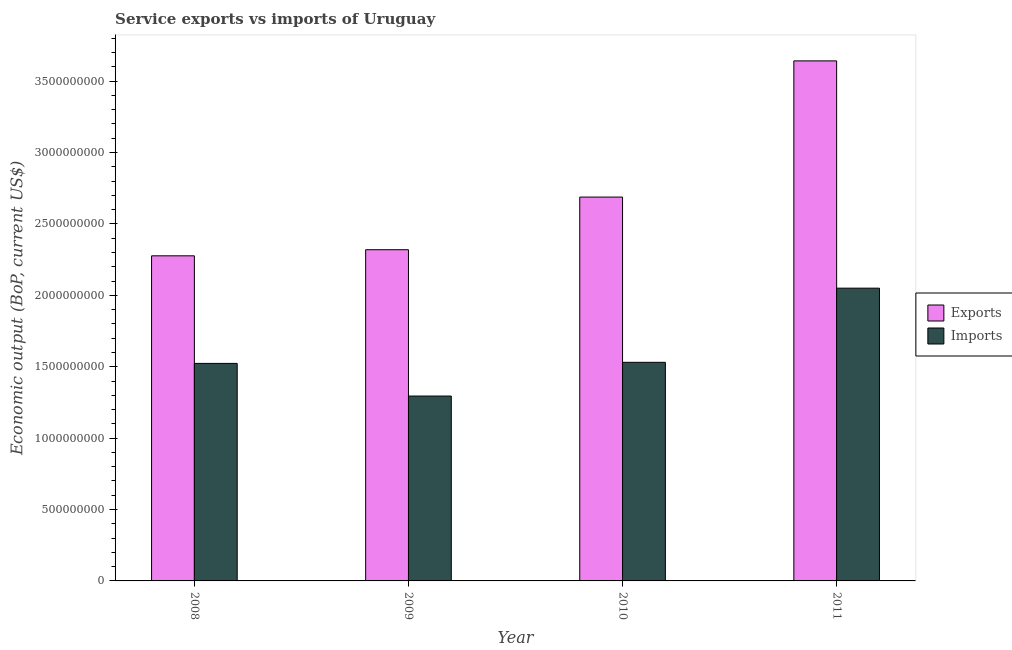How many different coloured bars are there?
Keep it short and to the point. 2. How many groups of bars are there?
Your answer should be compact. 4. Are the number of bars per tick equal to the number of legend labels?
Offer a terse response. Yes. Are the number of bars on each tick of the X-axis equal?
Provide a short and direct response. Yes. What is the label of the 1st group of bars from the left?
Your answer should be compact. 2008. What is the amount of service imports in 2010?
Your answer should be compact. 1.53e+09. Across all years, what is the maximum amount of service imports?
Your response must be concise. 2.05e+09. Across all years, what is the minimum amount of service imports?
Make the answer very short. 1.29e+09. In which year was the amount of service exports maximum?
Offer a very short reply. 2011. What is the total amount of service imports in the graph?
Offer a very short reply. 6.40e+09. What is the difference between the amount of service imports in 2008 and that in 2010?
Ensure brevity in your answer.  -7.59e+06. What is the difference between the amount of service imports in 2008 and the amount of service exports in 2010?
Make the answer very short. -7.59e+06. What is the average amount of service imports per year?
Make the answer very short. 1.60e+09. In the year 2011, what is the difference between the amount of service exports and amount of service imports?
Ensure brevity in your answer.  0. In how many years, is the amount of service exports greater than 2200000000 US$?
Offer a very short reply. 4. What is the ratio of the amount of service exports in 2010 to that in 2011?
Offer a terse response. 0.74. Is the amount of service imports in 2009 less than that in 2010?
Ensure brevity in your answer.  Yes. Is the difference between the amount of service exports in 2009 and 2011 greater than the difference between the amount of service imports in 2009 and 2011?
Your response must be concise. No. What is the difference between the highest and the second highest amount of service exports?
Keep it short and to the point. 9.54e+08. What is the difference between the highest and the lowest amount of service exports?
Offer a very short reply. 1.37e+09. What does the 2nd bar from the left in 2011 represents?
Your answer should be very brief. Imports. What does the 1st bar from the right in 2010 represents?
Provide a short and direct response. Imports. How many bars are there?
Keep it short and to the point. 8. How many years are there in the graph?
Keep it short and to the point. 4. Does the graph contain any zero values?
Make the answer very short. No. Does the graph contain grids?
Your answer should be very brief. No. Where does the legend appear in the graph?
Your answer should be very brief. Center right. What is the title of the graph?
Keep it short and to the point. Service exports vs imports of Uruguay. What is the label or title of the Y-axis?
Your response must be concise. Economic output (BoP, current US$). What is the Economic output (BoP, current US$) of Exports in 2008?
Your answer should be very brief. 2.28e+09. What is the Economic output (BoP, current US$) in Imports in 2008?
Offer a very short reply. 1.52e+09. What is the Economic output (BoP, current US$) in Exports in 2009?
Keep it short and to the point. 2.32e+09. What is the Economic output (BoP, current US$) of Imports in 2009?
Provide a succinct answer. 1.29e+09. What is the Economic output (BoP, current US$) in Exports in 2010?
Give a very brief answer. 2.69e+09. What is the Economic output (BoP, current US$) of Imports in 2010?
Your response must be concise. 1.53e+09. What is the Economic output (BoP, current US$) in Exports in 2011?
Your answer should be compact. 3.64e+09. What is the Economic output (BoP, current US$) of Imports in 2011?
Provide a short and direct response. 2.05e+09. Across all years, what is the maximum Economic output (BoP, current US$) in Exports?
Make the answer very short. 3.64e+09. Across all years, what is the maximum Economic output (BoP, current US$) in Imports?
Your answer should be compact. 2.05e+09. Across all years, what is the minimum Economic output (BoP, current US$) in Exports?
Your answer should be very brief. 2.28e+09. Across all years, what is the minimum Economic output (BoP, current US$) in Imports?
Offer a very short reply. 1.29e+09. What is the total Economic output (BoP, current US$) in Exports in the graph?
Ensure brevity in your answer.  1.09e+1. What is the total Economic output (BoP, current US$) in Imports in the graph?
Make the answer very short. 6.40e+09. What is the difference between the Economic output (BoP, current US$) of Exports in 2008 and that in 2009?
Ensure brevity in your answer.  -4.27e+07. What is the difference between the Economic output (BoP, current US$) in Imports in 2008 and that in 2009?
Make the answer very short. 2.29e+08. What is the difference between the Economic output (BoP, current US$) of Exports in 2008 and that in 2010?
Your response must be concise. -4.11e+08. What is the difference between the Economic output (BoP, current US$) in Imports in 2008 and that in 2010?
Your answer should be compact. -7.59e+06. What is the difference between the Economic output (BoP, current US$) of Exports in 2008 and that in 2011?
Offer a very short reply. -1.37e+09. What is the difference between the Economic output (BoP, current US$) in Imports in 2008 and that in 2011?
Keep it short and to the point. -5.27e+08. What is the difference between the Economic output (BoP, current US$) in Exports in 2009 and that in 2010?
Ensure brevity in your answer.  -3.69e+08. What is the difference between the Economic output (BoP, current US$) in Imports in 2009 and that in 2010?
Make the answer very short. -2.36e+08. What is the difference between the Economic output (BoP, current US$) in Exports in 2009 and that in 2011?
Keep it short and to the point. -1.32e+09. What is the difference between the Economic output (BoP, current US$) in Imports in 2009 and that in 2011?
Keep it short and to the point. -7.56e+08. What is the difference between the Economic output (BoP, current US$) of Exports in 2010 and that in 2011?
Your answer should be compact. -9.54e+08. What is the difference between the Economic output (BoP, current US$) of Imports in 2010 and that in 2011?
Keep it short and to the point. -5.19e+08. What is the difference between the Economic output (BoP, current US$) of Exports in 2008 and the Economic output (BoP, current US$) of Imports in 2009?
Your response must be concise. 9.82e+08. What is the difference between the Economic output (BoP, current US$) in Exports in 2008 and the Economic output (BoP, current US$) in Imports in 2010?
Your answer should be compact. 7.46e+08. What is the difference between the Economic output (BoP, current US$) in Exports in 2008 and the Economic output (BoP, current US$) in Imports in 2011?
Offer a very short reply. 2.26e+08. What is the difference between the Economic output (BoP, current US$) of Exports in 2009 and the Economic output (BoP, current US$) of Imports in 2010?
Provide a succinct answer. 7.89e+08. What is the difference between the Economic output (BoP, current US$) in Exports in 2009 and the Economic output (BoP, current US$) in Imports in 2011?
Offer a terse response. 2.69e+08. What is the difference between the Economic output (BoP, current US$) of Exports in 2010 and the Economic output (BoP, current US$) of Imports in 2011?
Provide a short and direct response. 6.38e+08. What is the average Economic output (BoP, current US$) of Exports per year?
Ensure brevity in your answer.  2.73e+09. What is the average Economic output (BoP, current US$) of Imports per year?
Ensure brevity in your answer.  1.60e+09. In the year 2008, what is the difference between the Economic output (BoP, current US$) of Exports and Economic output (BoP, current US$) of Imports?
Your answer should be compact. 7.53e+08. In the year 2009, what is the difference between the Economic output (BoP, current US$) of Exports and Economic output (BoP, current US$) of Imports?
Give a very brief answer. 1.02e+09. In the year 2010, what is the difference between the Economic output (BoP, current US$) of Exports and Economic output (BoP, current US$) of Imports?
Your answer should be compact. 1.16e+09. In the year 2011, what is the difference between the Economic output (BoP, current US$) in Exports and Economic output (BoP, current US$) in Imports?
Your response must be concise. 1.59e+09. What is the ratio of the Economic output (BoP, current US$) in Exports in 2008 to that in 2009?
Your response must be concise. 0.98. What is the ratio of the Economic output (BoP, current US$) in Imports in 2008 to that in 2009?
Provide a succinct answer. 1.18. What is the ratio of the Economic output (BoP, current US$) of Exports in 2008 to that in 2010?
Ensure brevity in your answer.  0.85. What is the ratio of the Economic output (BoP, current US$) in Exports in 2008 to that in 2011?
Ensure brevity in your answer.  0.63. What is the ratio of the Economic output (BoP, current US$) in Imports in 2008 to that in 2011?
Offer a very short reply. 0.74. What is the ratio of the Economic output (BoP, current US$) in Exports in 2009 to that in 2010?
Ensure brevity in your answer.  0.86. What is the ratio of the Economic output (BoP, current US$) in Imports in 2009 to that in 2010?
Your answer should be very brief. 0.85. What is the ratio of the Economic output (BoP, current US$) in Exports in 2009 to that in 2011?
Provide a succinct answer. 0.64. What is the ratio of the Economic output (BoP, current US$) in Imports in 2009 to that in 2011?
Your response must be concise. 0.63. What is the ratio of the Economic output (BoP, current US$) in Exports in 2010 to that in 2011?
Provide a succinct answer. 0.74. What is the ratio of the Economic output (BoP, current US$) in Imports in 2010 to that in 2011?
Your answer should be very brief. 0.75. What is the difference between the highest and the second highest Economic output (BoP, current US$) in Exports?
Give a very brief answer. 9.54e+08. What is the difference between the highest and the second highest Economic output (BoP, current US$) in Imports?
Give a very brief answer. 5.19e+08. What is the difference between the highest and the lowest Economic output (BoP, current US$) of Exports?
Your answer should be compact. 1.37e+09. What is the difference between the highest and the lowest Economic output (BoP, current US$) of Imports?
Give a very brief answer. 7.56e+08. 